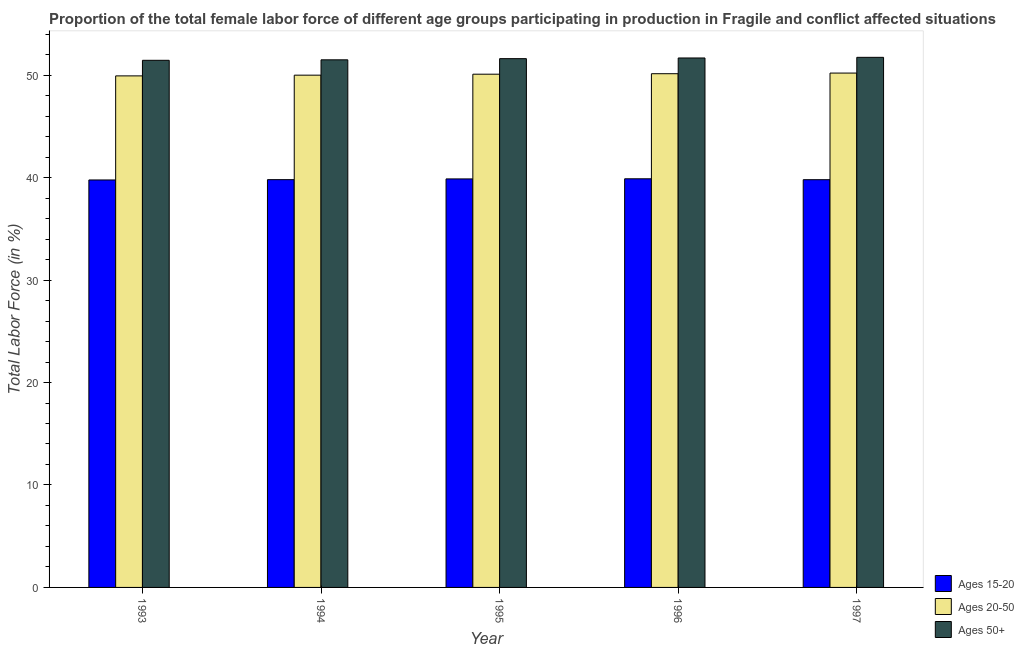How many groups of bars are there?
Offer a very short reply. 5. How many bars are there on the 3rd tick from the left?
Provide a short and direct response. 3. What is the label of the 1st group of bars from the left?
Your answer should be very brief. 1993. In how many cases, is the number of bars for a given year not equal to the number of legend labels?
Provide a succinct answer. 0. What is the percentage of female labor force within the age group 15-20 in 1994?
Provide a short and direct response. 39.8. Across all years, what is the maximum percentage of female labor force within the age group 15-20?
Ensure brevity in your answer.  39.89. Across all years, what is the minimum percentage of female labor force within the age group 15-20?
Provide a succinct answer. 39.77. In which year was the percentage of female labor force above age 50 minimum?
Provide a succinct answer. 1993. What is the total percentage of female labor force within the age group 20-50 in the graph?
Give a very brief answer. 250.38. What is the difference between the percentage of female labor force within the age group 15-20 in 1993 and that in 1997?
Keep it short and to the point. -0.03. What is the difference between the percentage of female labor force above age 50 in 1997 and the percentage of female labor force within the age group 20-50 in 1994?
Make the answer very short. 0.24. What is the average percentage of female labor force within the age group 15-20 per year?
Your answer should be compact. 39.83. In how many years, is the percentage of female labor force above age 50 greater than 34 %?
Offer a very short reply. 5. What is the ratio of the percentage of female labor force within the age group 20-50 in 1994 to that in 1995?
Provide a succinct answer. 1. Is the difference between the percentage of female labor force within the age group 15-20 in 1994 and 1995 greater than the difference between the percentage of female labor force above age 50 in 1994 and 1995?
Provide a succinct answer. No. What is the difference between the highest and the second highest percentage of female labor force within the age group 15-20?
Your answer should be compact. 0.01. What is the difference between the highest and the lowest percentage of female labor force within the age group 20-50?
Ensure brevity in your answer.  0.27. Is the sum of the percentage of female labor force above age 50 in 1995 and 1996 greater than the maximum percentage of female labor force within the age group 15-20 across all years?
Ensure brevity in your answer.  Yes. What does the 2nd bar from the left in 1993 represents?
Provide a succinct answer. Ages 20-50. What does the 2nd bar from the right in 1997 represents?
Offer a terse response. Ages 20-50. Is it the case that in every year, the sum of the percentage of female labor force within the age group 15-20 and percentage of female labor force within the age group 20-50 is greater than the percentage of female labor force above age 50?
Make the answer very short. Yes. How many bars are there?
Give a very brief answer. 15. How many years are there in the graph?
Your answer should be very brief. 5. Does the graph contain grids?
Make the answer very short. No. What is the title of the graph?
Ensure brevity in your answer.  Proportion of the total female labor force of different age groups participating in production in Fragile and conflict affected situations. Does "Other sectors" appear as one of the legend labels in the graph?
Give a very brief answer. No. What is the label or title of the X-axis?
Your answer should be compact. Year. What is the Total Labor Force (in %) of Ages 15-20 in 1993?
Keep it short and to the point. 39.77. What is the Total Labor Force (in %) of Ages 20-50 in 1993?
Give a very brief answer. 49.93. What is the Total Labor Force (in %) in Ages 50+ in 1993?
Offer a very short reply. 51.45. What is the Total Labor Force (in %) of Ages 15-20 in 1994?
Give a very brief answer. 39.8. What is the Total Labor Force (in %) in Ages 20-50 in 1994?
Make the answer very short. 50. What is the Total Labor Force (in %) of Ages 50+ in 1994?
Offer a very short reply. 51.5. What is the Total Labor Force (in %) in Ages 15-20 in 1995?
Ensure brevity in your answer.  39.88. What is the Total Labor Force (in %) of Ages 20-50 in 1995?
Your answer should be very brief. 50.1. What is the Total Labor Force (in %) in Ages 50+ in 1995?
Ensure brevity in your answer.  51.61. What is the Total Labor Force (in %) of Ages 15-20 in 1996?
Provide a short and direct response. 39.89. What is the Total Labor Force (in %) of Ages 20-50 in 1996?
Offer a terse response. 50.14. What is the Total Labor Force (in %) in Ages 50+ in 1996?
Your response must be concise. 51.68. What is the Total Labor Force (in %) in Ages 15-20 in 1997?
Ensure brevity in your answer.  39.8. What is the Total Labor Force (in %) of Ages 20-50 in 1997?
Provide a short and direct response. 50.21. What is the Total Labor Force (in %) of Ages 50+ in 1997?
Ensure brevity in your answer.  51.74. Across all years, what is the maximum Total Labor Force (in %) in Ages 15-20?
Your answer should be very brief. 39.89. Across all years, what is the maximum Total Labor Force (in %) in Ages 20-50?
Offer a terse response. 50.21. Across all years, what is the maximum Total Labor Force (in %) of Ages 50+?
Give a very brief answer. 51.74. Across all years, what is the minimum Total Labor Force (in %) of Ages 15-20?
Offer a very short reply. 39.77. Across all years, what is the minimum Total Labor Force (in %) of Ages 20-50?
Keep it short and to the point. 49.93. Across all years, what is the minimum Total Labor Force (in %) in Ages 50+?
Your answer should be compact. 51.45. What is the total Total Labor Force (in %) of Ages 15-20 in the graph?
Provide a short and direct response. 199.13. What is the total Total Labor Force (in %) of Ages 20-50 in the graph?
Offer a very short reply. 250.38. What is the total Total Labor Force (in %) of Ages 50+ in the graph?
Provide a short and direct response. 257.99. What is the difference between the Total Labor Force (in %) of Ages 15-20 in 1993 and that in 1994?
Ensure brevity in your answer.  -0.03. What is the difference between the Total Labor Force (in %) of Ages 20-50 in 1993 and that in 1994?
Your answer should be compact. -0.07. What is the difference between the Total Labor Force (in %) in Ages 50+ in 1993 and that in 1994?
Keep it short and to the point. -0.05. What is the difference between the Total Labor Force (in %) of Ages 15-20 in 1993 and that in 1995?
Your answer should be very brief. -0.1. What is the difference between the Total Labor Force (in %) in Ages 20-50 in 1993 and that in 1995?
Make the answer very short. -0.16. What is the difference between the Total Labor Force (in %) in Ages 50+ in 1993 and that in 1995?
Offer a terse response. -0.16. What is the difference between the Total Labor Force (in %) in Ages 15-20 in 1993 and that in 1996?
Provide a succinct answer. -0.11. What is the difference between the Total Labor Force (in %) of Ages 20-50 in 1993 and that in 1996?
Offer a very short reply. -0.21. What is the difference between the Total Labor Force (in %) in Ages 50+ in 1993 and that in 1996?
Give a very brief answer. -0.23. What is the difference between the Total Labor Force (in %) in Ages 15-20 in 1993 and that in 1997?
Your response must be concise. -0.03. What is the difference between the Total Labor Force (in %) in Ages 20-50 in 1993 and that in 1997?
Keep it short and to the point. -0.27. What is the difference between the Total Labor Force (in %) in Ages 50+ in 1993 and that in 1997?
Your answer should be compact. -0.29. What is the difference between the Total Labor Force (in %) of Ages 15-20 in 1994 and that in 1995?
Ensure brevity in your answer.  -0.07. What is the difference between the Total Labor Force (in %) in Ages 20-50 in 1994 and that in 1995?
Make the answer very short. -0.09. What is the difference between the Total Labor Force (in %) in Ages 50+ in 1994 and that in 1995?
Give a very brief answer. -0.11. What is the difference between the Total Labor Force (in %) in Ages 15-20 in 1994 and that in 1996?
Your answer should be compact. -0.08. What is the difference between the Total Labor Force (in %) in Ages 20-50 in 1994 and that in 1996?
Provide a short and direct response. -0.14. What is the difference between the Total Labor Force (in %) of Ages 50+ in 1994 and that in 1996?
Keep it short and to the point. -0.18. What is the difference between the Total Labor Force (in %) in Ages 15-20 in 1994 and that in 1997?
Give a very brief answer. 0. What is the difference between the Total Labor Force (in %) in Ages 20-50 in 1994 and that in 1997?
Provide a short and direct response. -0.2. What is the difference between the Total Labor Force (in %) of Ages 50+ in 1994 and that in 1997?
Offer a terse response. -0.24. What is the difference between the Total Labor Force (in %) in Ages 15-20 in 1995 and that in 1996?
Offer a very short reply. -0.01. What is the difference between the Total Labor Force (in %) in Ages 20-50 in 1995 and that in 1996?
Provide a short and direct response. -0.05. What is the difference between the Total Labor Force (in %) in Ages 50+ in 1995 and that in 1996?
Make the answer very short. -0.07. What is the difference between the Total Labor Force (in %) in Ages 15-20 in 1995 and that in 1997?
Ensure brevity in your answer.  0.08. What is the difference between the Total Labor Force (in %) of Ages 20-50 in 1995 and that in 1997?
Provide a short and direct response. -0.11. What is the difference between the Total Labor Force (in %) of Ages 50+ in 1995 and that in 1997?
Your answer should be compact. -0.13. What is the difference between the Total Labor Force (in %) of Ages 15-20 in 1996 and that in 1997?
Give a very brief answer. 0.09. What is the difference between the Total Labor Force (in %) in Ages 20-50 in 1996 and that in 1997?
Keep it short and to the point. -0.06. What is the difference between the Total Labor Force (in %) in Ages 50+ in 1996 and that in 1997?
Offer a very short reply. -0.06. What is the difference between the Total Labor Force (in %) of Ages 15-20 in 1993 and the Total Labor Force (in %) of Ages 20-50 in 1994?
Your response must be concise. -10.23. What is the difference between the Total Labor Force (in %) of Ages 15-20 in 1993 and the Total Labor Force (in %) of Ages 50+ in 1994?
Your answer should be compact. -11.73. What is the difference between the Total Labor Force (in %) of Ages 20-50 in 1993 and the Total Labor Force (in %) of Ages 50+ in 1994?
Your answer should be compact. -1.57. What is the difference between the Total Labor Force (in %) in Ages 15-20 in 1993 and the Total Labor Force (in %) in Ages 20-50 in 1995?
Make the answer very short. -10.32. What is the difference between the Total Labor Force (in %) of Ages 15-20 in 1993 and the Total Labor Force (in %) of Ages 50+ in 1995?
Provide a short and direct response. -11.84. What is the difference between the Total Labor Force (in %) of Ages 20-50 in 1993 and the Total Labor Force (in %) of Ages 50+ in 1995?
Offer a very short reply. -1.68. What is the difference between the Total Labor Force (in %) in Ages 15-20 in 1993 and the Total Labor Force (in %) in Ages 20-50 in 1996?
Your answer should be very brief. -10.37. What is the difference between the Total Labor Force (in %) of Ages 15-20 in 1993 and the Total Labor Force (in %) of Ages 50+ in 1996?
Your answer should be compact. -11.91. What is the difference between the Total Labor Force (in %) in Ages 20-50 in 1993 and the Total Labor Force (in %) in Ages 50+ in 1996?
Ensure brevity in your answer.  -1.75. What is the difference between the Total Labor Force (in %) of Ages 15-20 in 1993 and the Total Labor Force (in %) of Ages 20-50 in 1997?
Your response must be concise. -10.43. What is the difference between the Total Labor Force (in %) in Ages 15-20 in 1993 and the Total Labor Force (in %) in Ages 50+ in 1997?
Provide a short and direct response. -11.97. What is the difference between the Total Labor Force (in %) of Ages 20-50 in 1993 and the Total Labor Force (in %) of Ages 50+ in 1997?
Keep it short and to the point. -1.81. What is the difference between the Total Labor Force (in %) in Ages 15-20 in 1994 and the Total Labor Force (in %) in Ages 20-50 in 1995?
Your answer should be compact. -10.29. What is the difference between the Total Labor Force (in %) in Ages 15-20 in 1994 and the Total Labor Force (in %) in Ages 50+ in 1995?
Keep it short and to the point. -11.81. What is the difference between the Total Labor Force (in %) of Ages 20-50 in 1994 and the Total Labor Force (in %) of Ages 50+ in 1995?
Offer a terse response. -1.61. What is the difference between the Total Labor Force (in %) of Ages 15-20 in 1994 and the Total Labor Force (in %) of Ages 20-50 in 1996?
Your answer should be compact. -10.34. What is the difference between the Total Labor Force (in %) of Ages 15-20 in 1994 and the Total Labor Force (in %) of Ages 50+ in 1996?
Ensure brevity in your answer.  -11.88. What is the difference between the Total Labor Force (in %) in Ages 20-50 in 1994 and the Total Labor Force (in %) in Ages 50+ in 1996?
Offer a very short reply. -1.68. What is the difference between the Total Labor Force (in %) in Ages 15-20 in 1994 and the Total Labor Force (in %) in Ages 20-50 in 1997?
Your answer should be compact. -10.4. What is the difference between the Total Labor Force (in %) in Ages 15-20 in 1994 and the Total Labor Force (in %) in Ages 50+ in 1997?
Offer a terse response. -11.94. What is the difference between the Total Labor Force (in %) in Ages 20-50 in 1994 and the Total Labor Force (in %) in Ages 50+ in 1997?
Provide a succinct answer. -1.74. What is the difference between the Total Labor Force (in %) of Ages 15-20 in 1995 and the Total Labor Force (in %) of Ages 20-50 in 1996?
Offer a terse response. -10.27. What is the difference between the Total Labor Force (in %) of Ages 15-20 in 1995 and the Total Labor Force (in %) of Ages 50+ in 1996?
Provide a succinct answer. -11.8. What is the difference between the Total Labor Force (in %) in Ages 20-50 in 1995 and the Total Labor Force (in %) in Ages 50+ in 1996?
Ensure brevity in your answer.  -1.58. What is the difference between the Total Labor Force (in %) in Ages 15-20 in 1995 and the Total Labor Force (in %) in Ages 20-50 in 1997?
Keep it short and to the point. -10.33. What is the difference between the Total Labor Force (in %) in Ages 15-20 in 1995 and the Total Labor Force (in %) in Ages 50+ in 1997?
Give a very brief answer. -11.87. What is the difference between the Total Labor Force (in %) of Ages 20-50 in 1995 and the Total Labor Force (in %) of Ages 50+ in 1997?
Your answer should be compact. -1.65. What is the difference between the Total Labor Force (in %) of Ages 15-20 in 1996 and the Total Labor Force (in %) of Ages 20-50 in 1997?
Your answer should be compact. -10.32. What is the difference between the Total Labor Force (in %) in Ages 15-20 in 1996 and the Total Labor Force (in %) in Ages 50+ in 1997?
Ensure brevity in your answer.  -11.86. What is the difference between the Total Labor Force (in %) in Ages 20-50 in 1996 and the Total Labor Force (in %) in Ages 50+ in 1997?
Offer a terse response. -1.6. What is the average Total Labor Force (in %) in Ages 15-20 per year?
Provide a succinct answer. 39.83. What is the average Total Labor Force (in %) of Ages 20-50 per year?
Provide a short and direct response. 50.08. What is the average Total Labor Force (in %) in Ages 50+ per year?
Offer a very short reply. 51.6. In the year 1993, what is the difference between the Total Labor Force (in %) in Ages 15-20 and Total Labor Force (in %) in Ages 20-50?
Make the answer very short. -10.16. In the year 1993, what is the difference between the Total Labor Force (in %) in Ages 15-20 and Total Labor Force (in %) in Ages 50+?
Your response must be concise. -11.68. In the year 1993, what is the difference between the Total Labor Force (in %) in Ages 20-50 and Total Labor Force (in %) in Ages 50+?
Ensure brevity in your answer.  -1.52. In the year 1994, what is the difference between the Total Labor Force (in %) of Ages 15-20 and Total Labor Force (in %) of Ages 20-50?
Offer a terse response. -10.2. In the year 1994, what is the difference between the Total Labor Force (in %) in Ages 15-20 and Total Labor Force (in %) in Ages 50+?
Keep it short and to the point. -11.7. In the year 1994, what is the difference between the Total Labor Force (in %) of Ages 20-50 and Total Labor Force (in %) of Ages 50+?
Make the answer very short. -1.5. In the year 1995, what is the difference between the Total Labor Force (in %) in Ages 15-20 and Total Labor Force (in %) in Ages 20-50?
Make the answer very short. -10.22. In the year 1995, what is the difference between the Total Labor Force (in %) in Ages 15-20 and Total Labor Force (in %) in Ages 50+?
Ensure brevity in your answer.  -11.74. In the year 1995, what is the difference between the Total Labor Force (in %) in Ages 20-50 and Total Labor Force (in %) in Ages 50+?
Provide a succinct answer. -1.52. In the year 1996, what is the difference between the Total Labor Force (in %) of Ages 15-20 and Total Labor Force (in %) of Ages 20-50?
Make the answer very short. -10.26. In the year 1996, what is the difference between the Total Labor Force (in %) in Ages 15-20 and Total Labor Force (in %) in Ages 50+?
Give a very brief answer. -11.79. In the year 1996, what is the difference between the Total Labor Force (in %) in Ages 20-50 and Total Labor Force (in %) in Ages 50+?
Provide a succinct answer. -1.54. In the year 1997, what is the difference between the Total Labor Force (in %) in Ages 15-20 and Total Labor Force (in %) in Ages 20-50?
Your answer should be compact. -10.41. In the year 1997, what is the difference between the Total Labor Force (in %) in Ages 15-20 and Total Labor Force (in %) in Ages 50+?
Your response must be concise. -11.94. In the year 1997, what is the difference between the Total Labor Force (in %) of Ages 20-50 and Total Labor Force (in %) of Ages 50+?
Provide a short and direct response. -1.54. What is the ratio of the Total Labor Force (in %) of Ages 15-20 in 1993 to that in 1994?
Make the answer very short. 1. What is the ratio of the Total Labor Force (in %) in Ages 50+ in 1993 to that in 1994?
Your answer should be compact. 1. What is the ratio of the Total Labor Force (in %) of Ages 20-50 in 1993 to that in 1995?
Ensure brevity in your answer.  1. What is the ratio of the Total Labor Force (in %) of Ages 50+ in 1993 to that in 1996?
Your response must be concise. 1. What is the ratio of the Total Labor Force (in %) of Ages 50+ in 1993 to that in 1997?
Provide a succinct answer. 0.99. What is the ratio of the Total Labor Force (in %) in Ages 20-50 in 1994 to that in 1995?
Offer a very short reply. 1. What is the ratio of the Total Labor Force (in %) in Ages 20-50 in 1994 to that in 1996?
Your answer should be very brief. 1. What is the ratio of the Total Labor Force (in %) in Ages 20-50 in 1994 to that in 1997?
Provide a short and direct response. 1. What is the ratio of the Total Labor Force (in %) in Ages 50+ in 1994 to that in 1997?
Keep it short and to the point. 1. What is the ratio of the Total Labor Force (in %) in Ages 15-20 in 1995 to that in 1996?
Provide a succinct answer. 1. What is the ratio of the Total Labor Force (in %) in Ages 20-50 in 1995 to that in 1996?
Your answer should be very brief. 1. What is the ratio of the Total Labor Force (in %) in Ages 50+ in 1995 to that in 1996?
Provide a short and direct response. 1. What is the ratio of the Total Labor Force (in %) of Ages 15-20 in 1996 to that in 1997?
Your answer should be very brief. 1. What is the ratio of the Total Labor Force (in %) of Ages 20-50 in 1996 to that in 1997?
Provide a succinct answer. 1. What is the ratio of the Total Labor Force (in %) in Ages 50+ in 1996 to that in 1997?
Your response must be concise. 1. What is the difference between the highest and the second highest Total Labor Force (in %) of Ages 15-20?
Your answer should be compact. 0.01. What is the difference between the highest and the second highest Total Labor Force (in %) of Ages 20-50?
Make the answer very short. 0.06. What is the difference between the highest and the second highest Total Labor Force (in %) of Ages 50+?
Provide a succinct answer. 0.06. What is the difference between the highest and the lowest Total Labor Force (in %) of Ages 15-20?
Your answer should be compact. 0.11. What is the difference between the highest and the lowest Total Labor Force (in %) of Ages 20-50?
Offer a very short reply. 0.27. What is the difference between the highest and the lowest Total Labor Force (in %) in Ages 50+?
Your response must be concise. 0.29. 